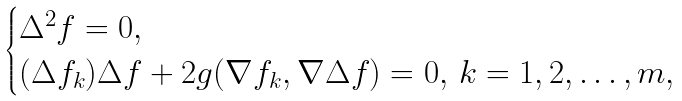Convert formula to latex. <formula><loc_0><loc_0><loc_500><loc_500>\begin{cases} \Delta ^ { 2 } f = 0 , \\ ( \Delta f _ { k } ) \Delta f + 2 g ( \nabla f _ { k } , \nabla \Delta f ) = 0 , \, k = 1 , 2 , \dots , m , \end{cases}</formula> 